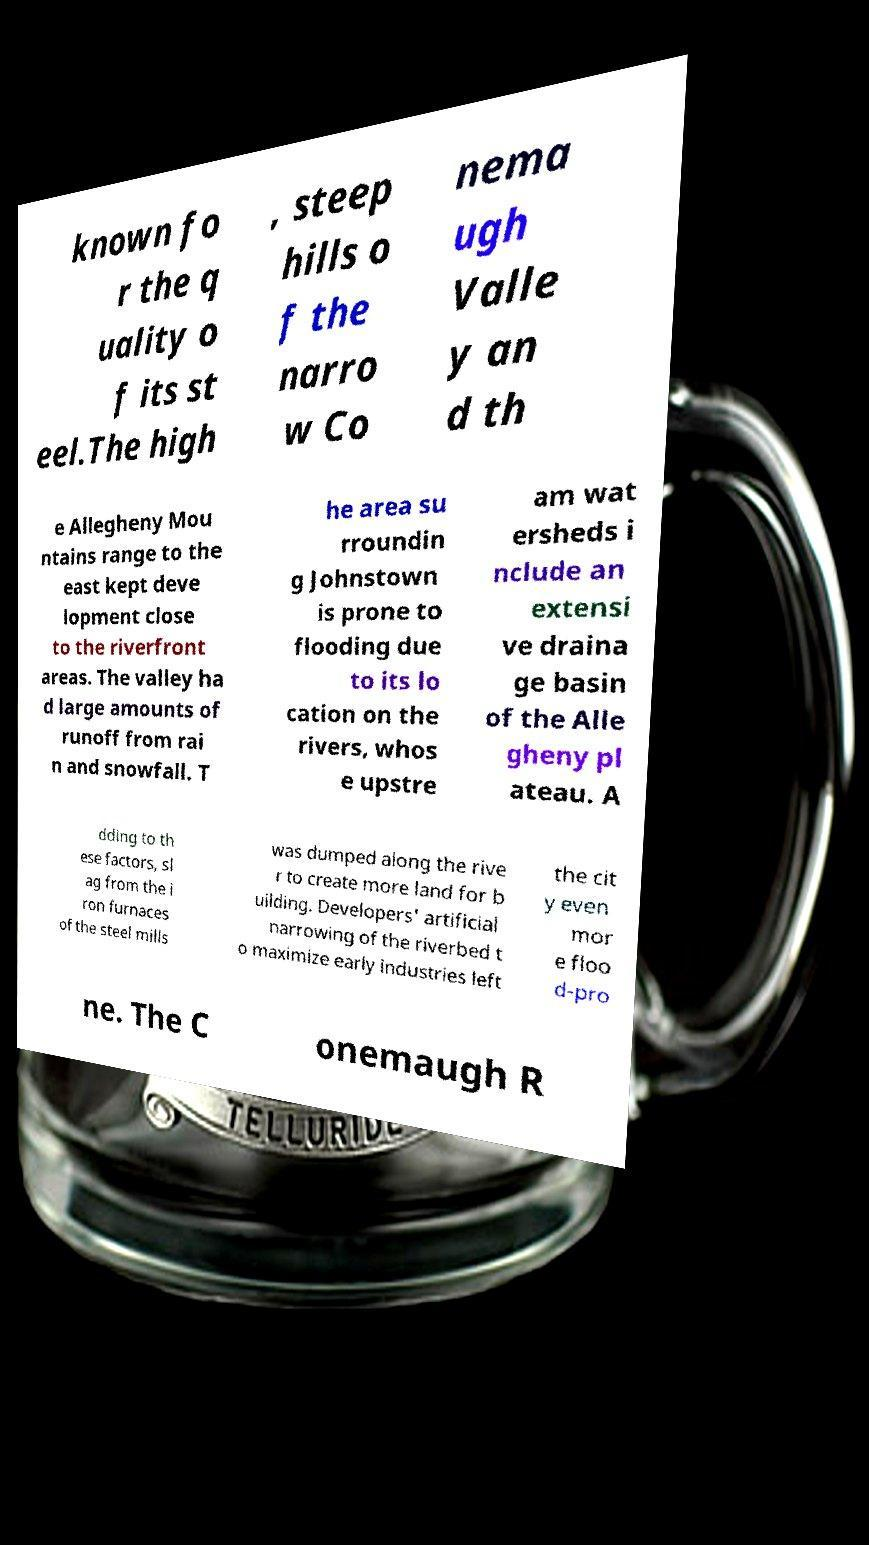Could you extract and type out the text from this image? known fo r the q uality o f its st eel.The high , steep hills o f the narro w Co nema ugh Valle y an d th e Allegheny Mou ntains range to the east kept deve lopment close to the riverfront areas. The valley ha d large amounts of runoff from rai n and snowfall. T he area su rroundin g Johnstown is prone to flooding due to its lo cation on the rivers, whos e upstre am wat ersheds i nclude an extensi ve draina ge basin of the Alle gheny pl ateau. A dding to th ese factors, sl ag from the i ron furnaces of the steel mills was dumped along the rive r to create more land for b uilding. Developers' artificial narrowing of the riverbed t o maximize early industries left the cit y even mor e floo d-pro ne. The C onemaugh R 